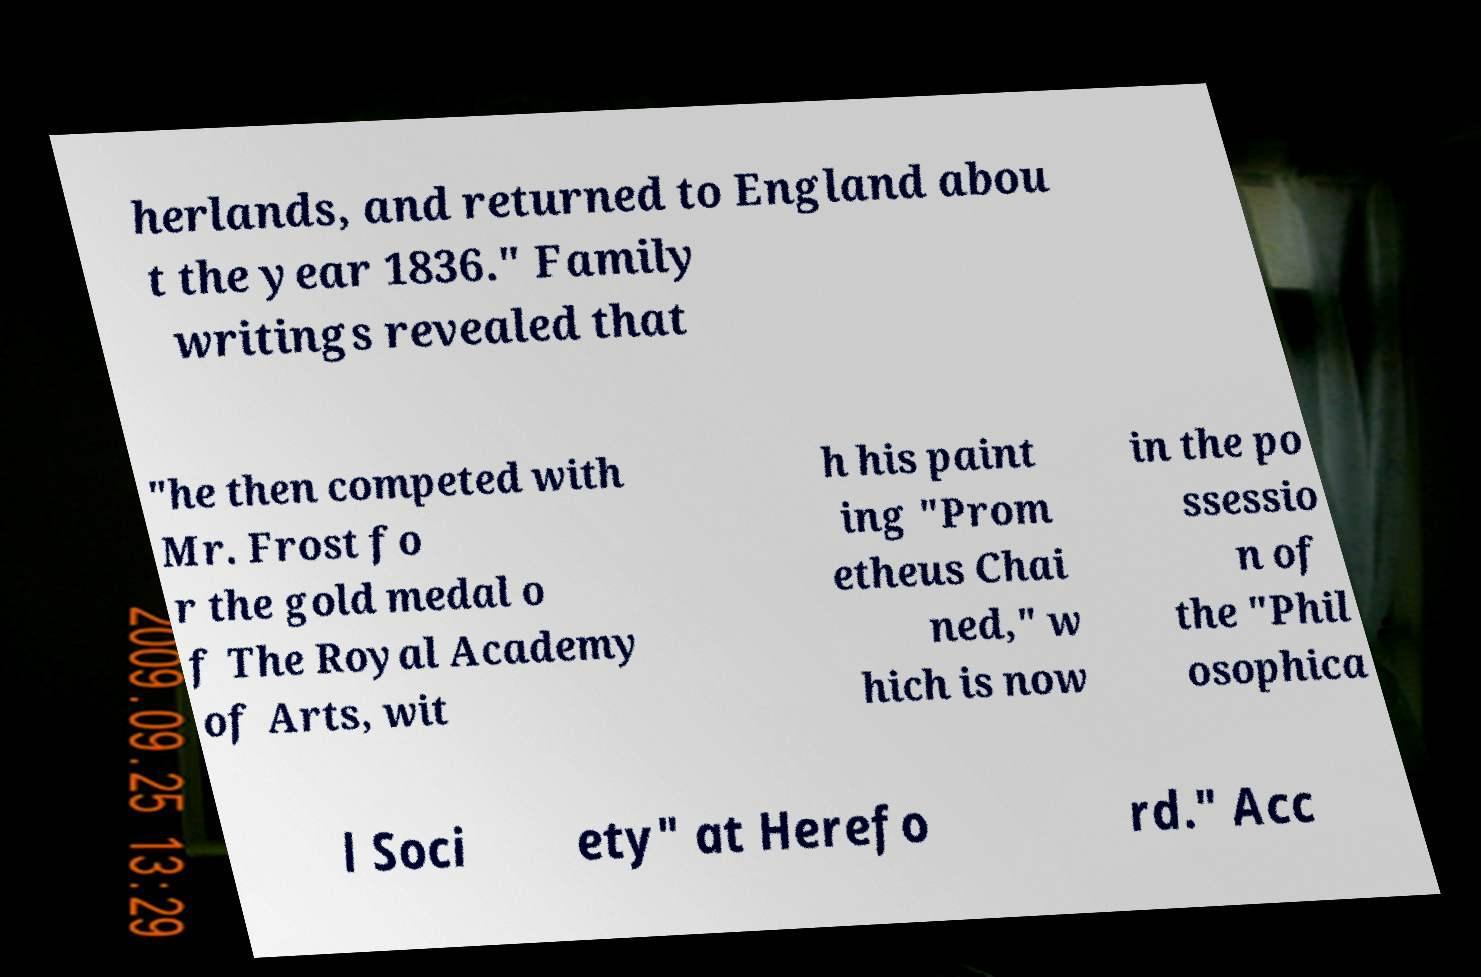Could you assist in decoding the text presented in this image and type it out clearly? herlands, and returned to England abou t the year 1836." Family writings revealed that "he then competed with Mr. Frost fo r the gold medal o f The Royal Academy of Arts, wit h his paint ing "Prom etheus Chai ned," w hich is now in the po ssessio n of the "Phil osophica l Soci ety" at Herefo rd." Acc 